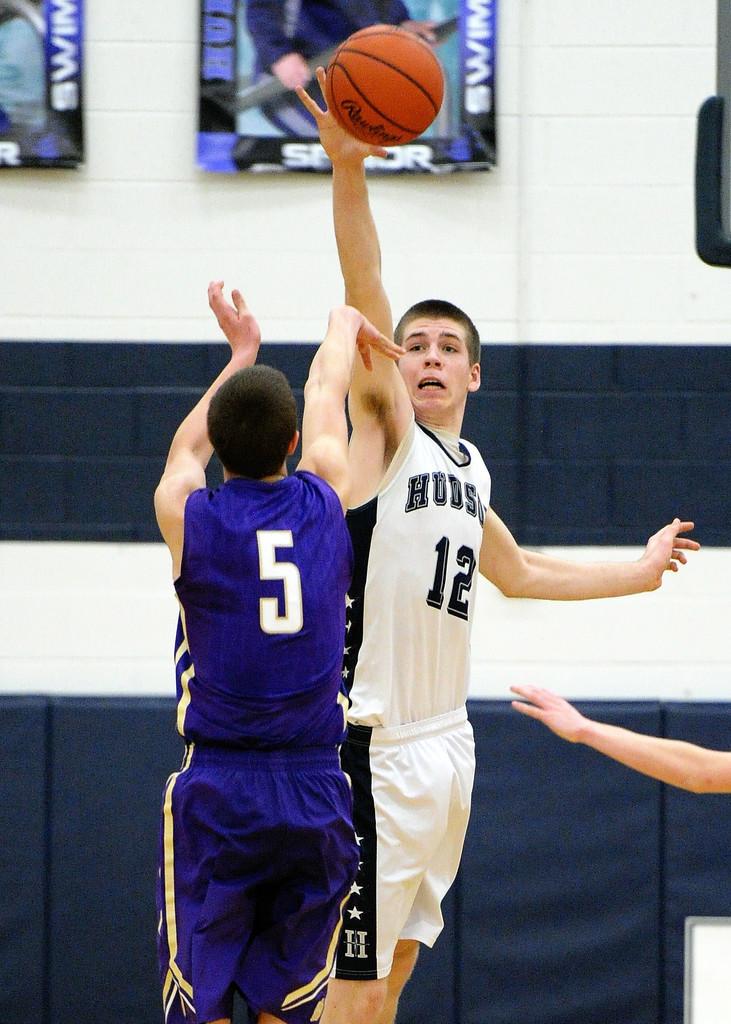What is the number of the player in blue?
Your answer should be compact. 5. What is the man in blues jersey number?
Ensure brevity in your answer.  5. 